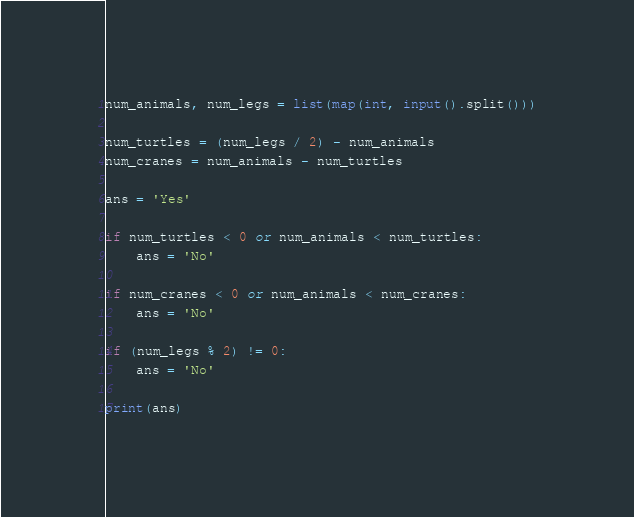Convert code to text. <code><loc_0><loc_0><loc_500><loc_500><_Python_>num_animals, num_legs = list(map(int, input().split()))

num_turtles = (num_legs / 2) - num_animals
num_cranes = num_animals - num_turtles

ans = 'Yes'

if num_turtles < 0 or num_animals < num_turtles:
    ans = 'No'

if num_cranes < 0 or num_animals < num_cranes:
    ans = 'No'

if (num_legs % 2) != 0:
    ans = 'No'

print(ans)
</code> 